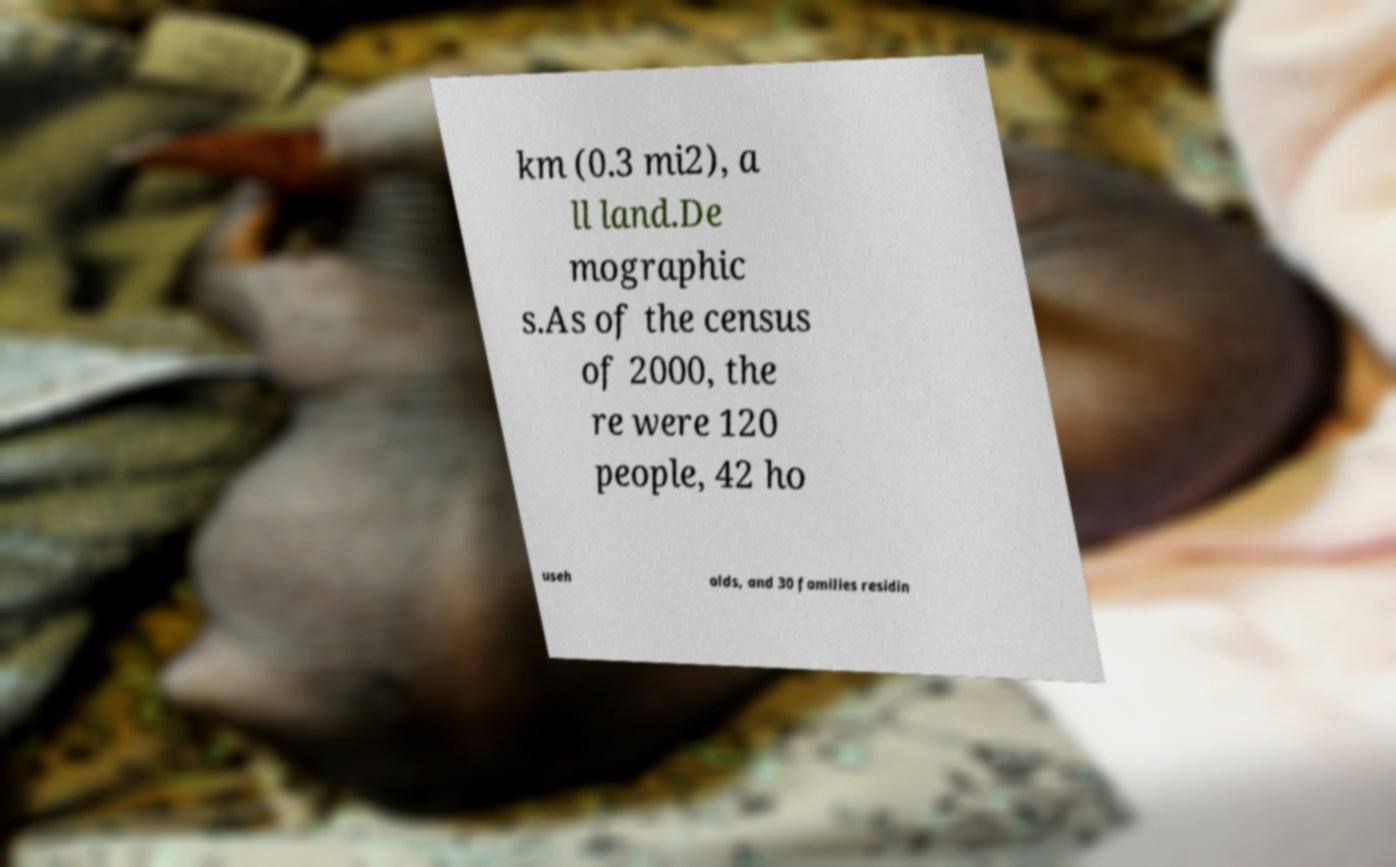I need the written content from this picture converted into text. Can you do that? km (0.3 mi2), a ll land.De mographic s.As of the census of 2000, the re were 120 people, 42 ho useh olds, and 30 families residin 